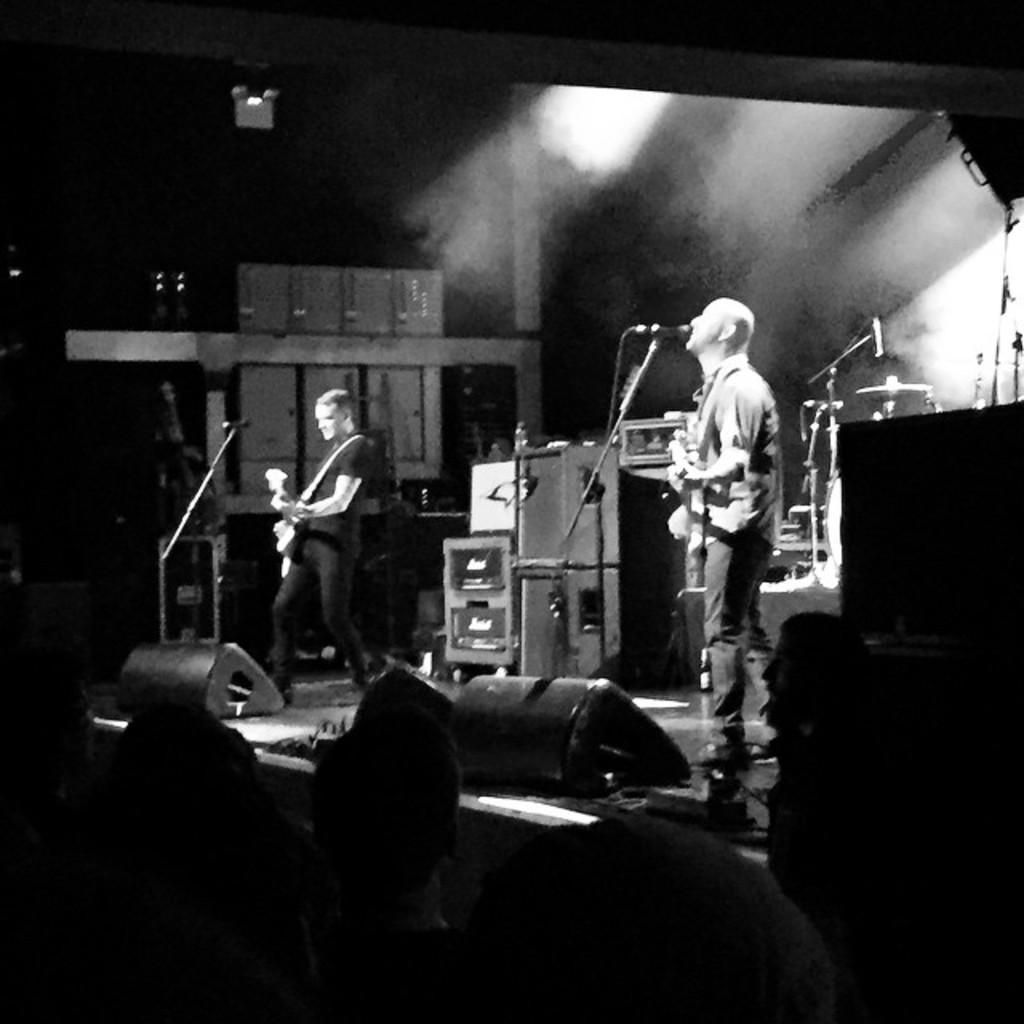Could you give a brief overview of what you see in this image? In this picture we can see a person is standing on a stage and playing guitar, and here is the microphone, and at right corner a person is standing and singing, and at down here are the group of people. 